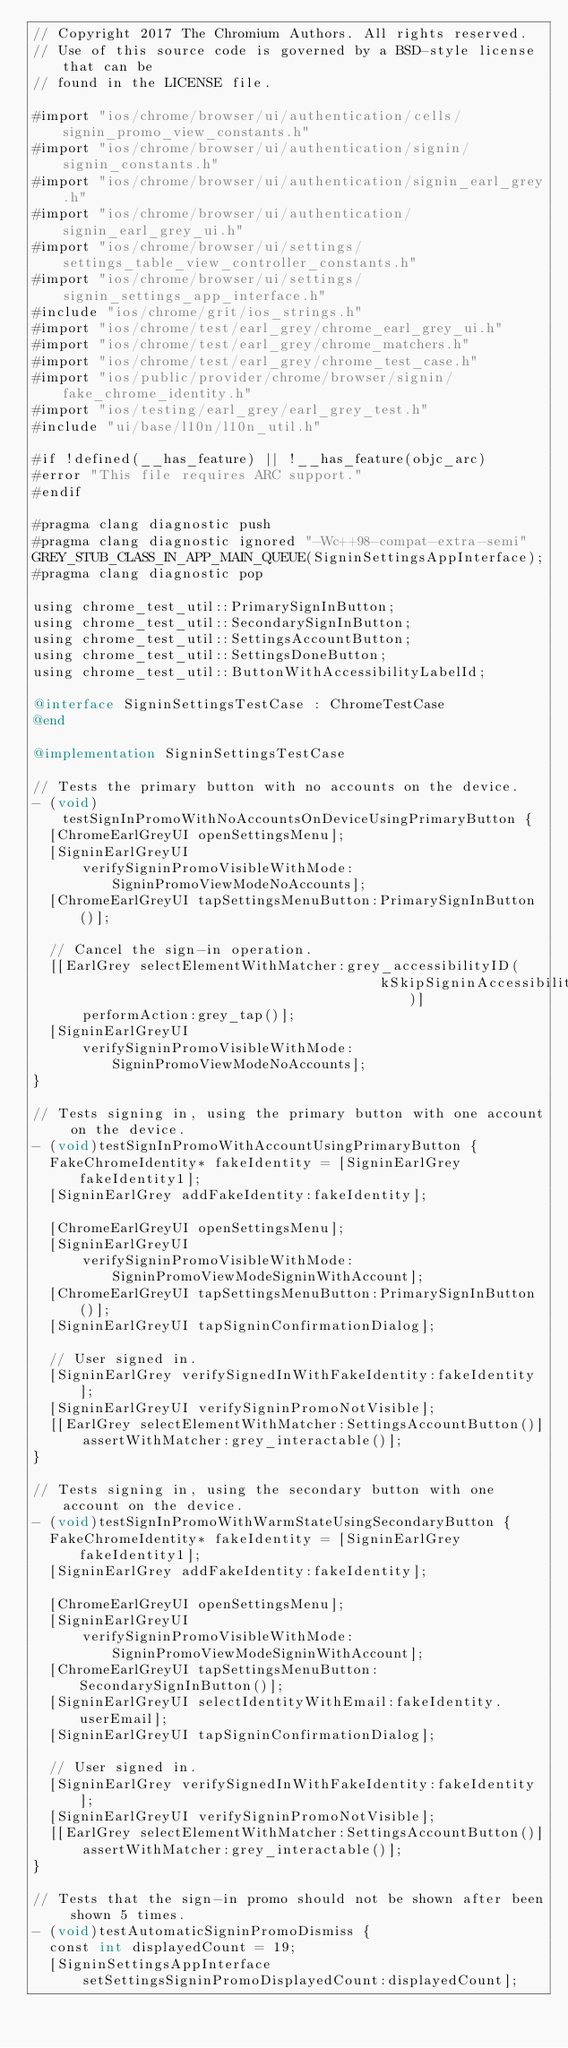Convert code to text. <code><loc_0><loc_0><loc_500><loc_500><_ObjectiveC_>// Copyright 2017 The Chromium Authors. All rights reserved.
// Use of this source code is governed by a BSD-style license that can be
// found in the LICENSE file.

#import "ios/chrome/browser/ui/authentication/cells/signin_promo_view_constants.h"
#import "ios/chrome/browser/ui/authentication/signin/signin_constants.h"
#import "ios/chrome/browser/ui/authentication/signin_earl_grey.h"
#import "ios/chrome/browser/ui/authentication/signin_earl_grey_ui.h"
#import "ios/chrome/browser/ui/settings/settings_table_view_controller_constants.h"
#import "ios/chrome/browser/ui/settings/signin_settings_app_interface.h"
#include "ios/chrome/grit/ios_strings.h"
#import "ios/chrome/test/earl_grey/chrome_earl_grey_ui.h"
#import "ios/chrome/test/earl_grey/chrome_matchers.h"
#import "ios/chrome/test/earl_grey/chrome_test_case.h"
#import "ios/public/provider/chrome/browser/signin/fake_chrome_identity.h"
#import "ios/testing/earl_grey/earl_grey_test.h"
#include "ui/base/l10n/l10n_util.h"

#if !defined(__has_feature) || !__has_feature(objc_arc)
#error "This file requires ARC support."
#endif

#pragma clang diagnostic push
#pragma clang diagnostic ignored "-Wc++98-compat-extra-semi"
GREY_STUB_CLASS_IN_APP_MAIN_QUEUE(SigninSettingsAppInterface);
#pragma clang diagnostic pop

using chrome_test_util::PrimarySignInButton;
using chrome_test_util::SecondarySignInButton;
using chrome_test_util::SettingsAccountButton;
using chrome_test_util::SettingsDoneButton;
using chrome_test_util::ButtonWithAccessibilityLabelId;

@interface SigninSettingsTestCase : ChromeTestCase
@end

@implementation SigninSettingsTestCase

// Tests the primary button with no accounts on the device.
- (void)testSignInPromoWithNoAccountsOnDeviceUsingPrimaryButton {
  [ChromeEarlGreyUI openSettingsMenu];
  [SigninEarlGreyUI
      verifySigninPromoVisibleWithMode:SigninPromoViewModeNoAccounts];
  [ChromeEarlGreyUI tapSettingsMenuButton:PrimarySignInButton()];

  // Cancel the sign-in operation.
  [[EarlGrey selectElementWithMatcher:grey_accessibilityID(
                                          kSkipSigninAccessibilityIdentifier)]
      performAction:grey_tap()];
  [SigninEarlGreyUI
      verifySigninPromoVisibleWithMode:SigninPromoViewModeNoAccounts];
}

// Tests signing in, using the primary button with one account on the device.
- (void)testSignInPromoWithAccountUsingPrimaryButton {
  FakeChromeIdentity* fakeIdentity = [SigninEarlGrey fakeIdentity1];
  [SigninEarlGrey addFakeIdentity:fakeIdentity];

  [ChromeEarlGreyUI openSettingsMenu];
  [SigninEarlGreyUI
      verifySigninPromoVisibleWithMode:SigninPromoViewModeSigninWithAccount];
  [ChromeEarlGreyUI tapSettingsMenuButton:PrimarySignInButton()];
  [SigninEarlGreyUI tapSigninConfirmationDialog];

  // User signed in.
  [SigninEarlGrey verifySignedInWithFakeIdentity:fakeIdentity];
  [SigninEarlGreyUI verifySigninPromoNotVisible];
  [[EarlGrey selectElementWithMatcher:SettingsAccountButton()]
      assertWithMatcher:grey_interactable()];
}

// Tests signing in, using the secondary button with one account on the device.
- (void)testSignInPromoWithWarmStateUsingSecondaryButton {
  FakeChromeIdentity* fakeIdentity = [SigninEarlGrey fakeIdentity1];
  [SigninEarlGrey addFakeIdentity:fakeIdentity];

  [ChromeEarlGreyUI openSettingsMenu];
  [SigninEarlGreyUI
      verifySigninPromoVisibleWithMode:SigninPromoViewModeSigninWithAccount];
  [ChromeEarlGreyUI tapSettingsMenuButton:SecondarySignInButton()];
  [SigninEarlGreyUI selectIdentityWithEmail:fakeIdentity.userEmail];
  [SigninEarlGreyUI tapSigninConfirmationDialog];

  // User signed in.
  [SigninEarlGrey verifySignedInWithFakeIdentity:fakeIdentity];
  [SigninEarlGreyUI verifySigninPromoNotVisible];
  [[EarlGrey selectElementWithMatcher:SettingsAccountButton()]
      assertWithMatcher:grey_interactable()];
}

// Tests that the sign-in promo should not be shown after been shown 5 times.
- (void)testAutomaticSigninPromoDismiss {
  const int displayedCount = 19;
  [SigninSettingsAppInterface
      setSettingsSigninPromoDisplayedCount:displayedCount];</code> 